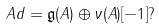<formula> <loc_0><loc_0><loc_500><loc_500>A d = \mathfrak { g } ( A ) \oplus \nu ( A ) [ - 1 ] ?</formula> 